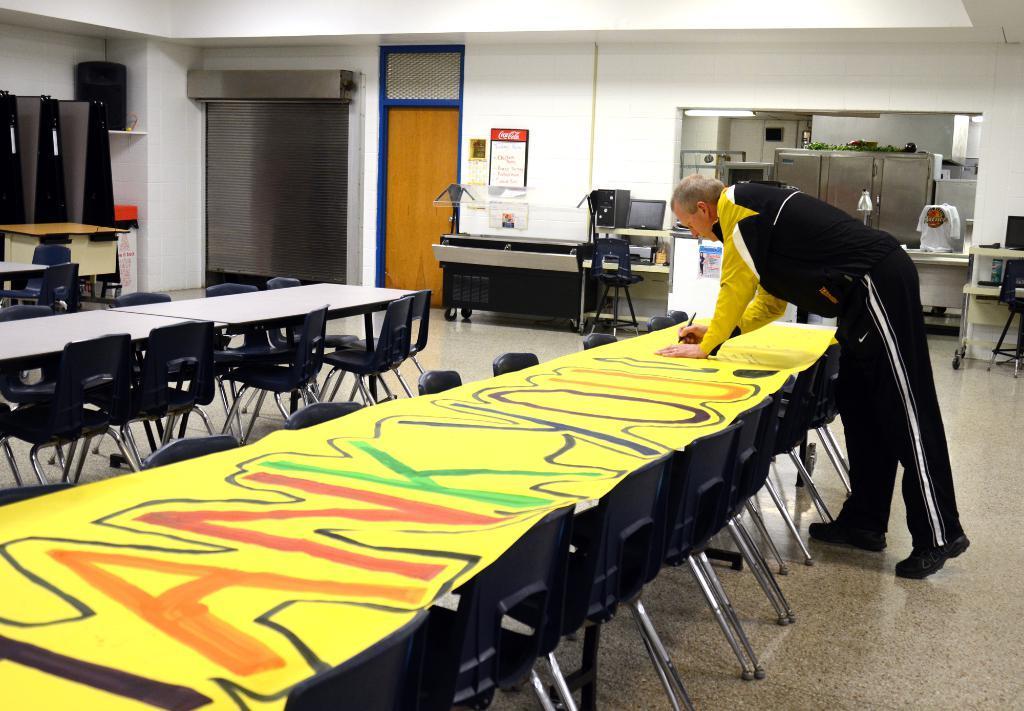Please provide a concise description of this image. In this image i can see a inside view of building. on the right side corner i can see a table along with chair. On the right side i can see a table ,on the table i can see a yellow color paper i can see black a man standing near to the table and his wearing yellow color shirt. On the middle corner i can see a another table, beside that i can a system and and back side there a wall and there is a paper on the wall. in the left corner i can see a door. in the left corner i can a table ,near to the table i can see a chairs and i can a wall. 